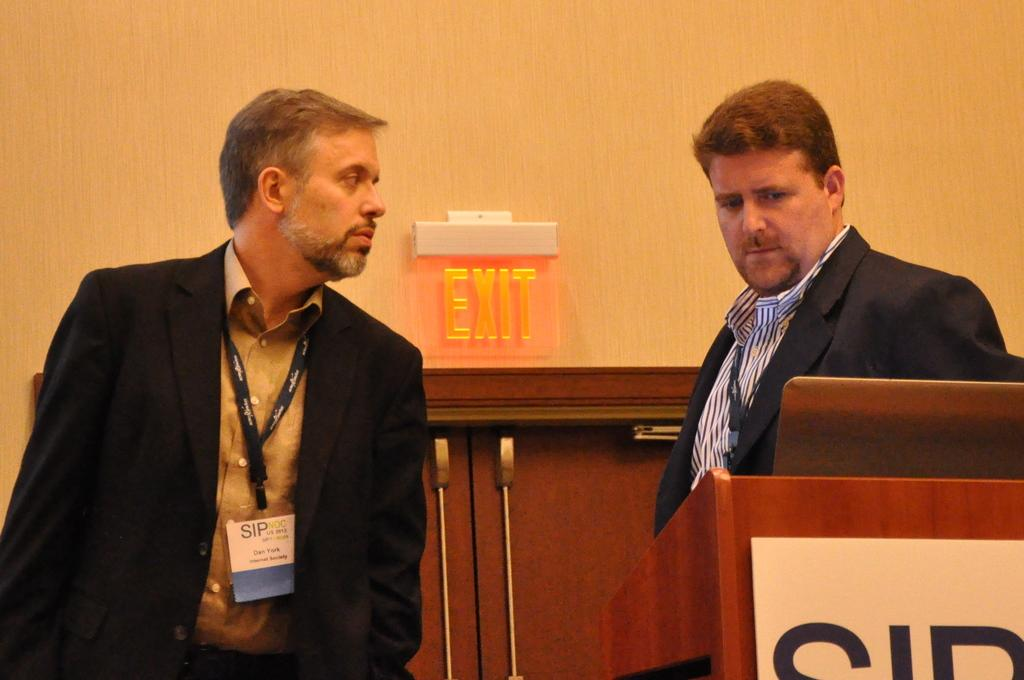How many people are in the foreground of the image? There are two men in the foreground of the image. What can be seen on the right side of the image? There is a table on the right side of the image. What is located in the background of the image? There is an exit door in the background of the image. What type of credit is being discussed by the two men in the image? There is no indication in the image that the two men are discussing any type of credit. 